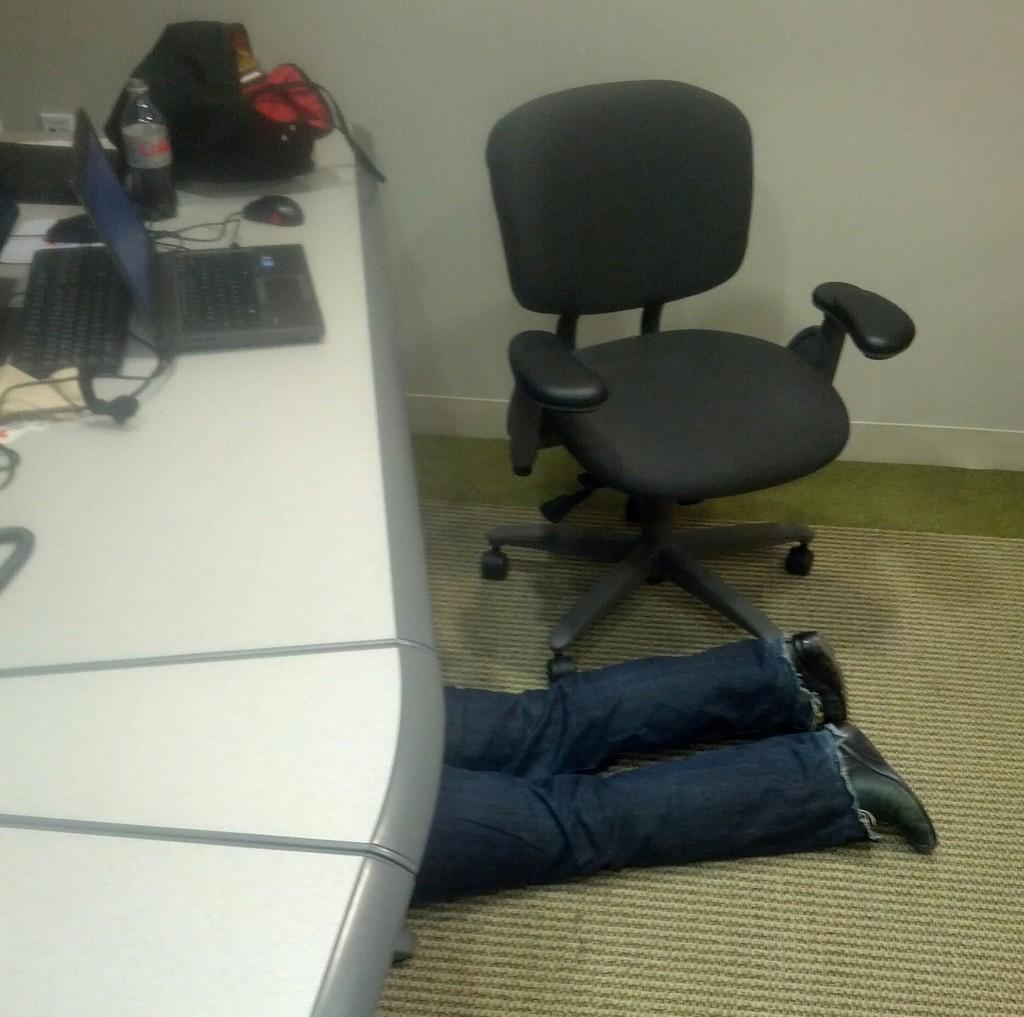Please provide a concise description of this image. In the image I can see a person who is under the table on which there is a laptop, bottle and some other things and also I can see a chair to the side. 